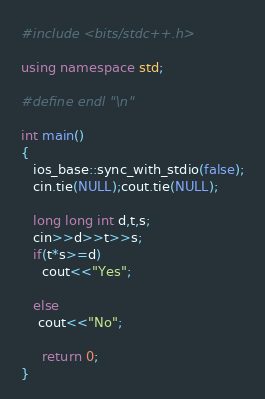<code> <loc_0><loc_0><loc_500><loc_500><_C++_>#include <bits/stdc++.h>

using namespace std;

#define endl "\n"

int main()
{
   ios_base::sync_with_stdio(false);
   cin.tie(NULL);cout.tie(NULL);
   
   long long int d,t,s;
   cin>>d>>t>>s;
   if(t*s>=d)
     cout<<"Yes";
     
   else
    cout<<"No";
   
     return 0;
}</code> 